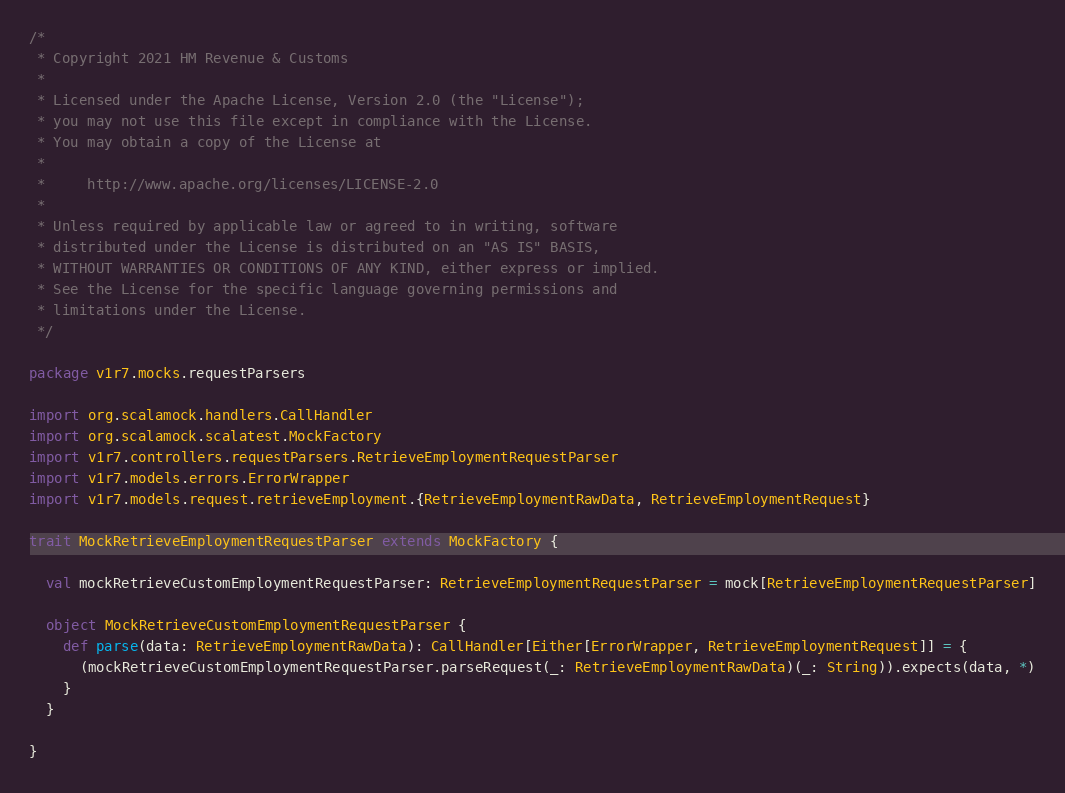<code> <loc_0><loc_0><loc_500><loc_500><_Scala_>/*
 * Copyright 2021 HM Revenue & Customs
 *
 * Licensed under the Apache License, Version 2.0 (the "License");
 * you may not use this file except in compliance with the License.
 * You may obtain a copy of the License at
 *
 *     http://www.apache.org/licenses/LICENSE-2.0
 *
 * Unless required by applicable law or agreed to in writing, software
 * distributed under the License is distributed on an "AS IS" BASIS,
 * WITHOUT WARRANTIES OR CONDITIONS OF ANY KIND, either express or implied.
 * See the License for the specific language governing permissions and
 * limitations under the License.
 */

package v1r7.mocks.requestParsers

import org.scalamock.handlers.CallHandler
import org.scalamock.scalatest.MockFactory
import v1r7.controllers.requestParsers.RetrieveEmploymentRequestParser
import v1r7.models.errors.ErrorWrapper
import v1r7.models.request.retrieveEmployment.{RetrieveEmploymentRawData, RetrieveEmploymentRequest}

trait MockRetrieveEmploymentRequestParser extends MockFactory {

  val mockRetrieveCustomEmploymentRequestParser: RetrieveEmploymentRequestParser = mock[RetrieveEmploymentRequestParser]

  object MockRetrieveCustomEmploymentRequestParser {
    def parse(data: RetrieveEmploymentRawData): CallHandler[Either[ErrorWrapper, RetrieveEmploymentRequest]] = {
      (mockRetrieveCustomEmploymentRequestParser.parseRequest(_: RetrieveEmploymentRawData)(_: String)).expects(data, *)
    }
  }

}</code> 